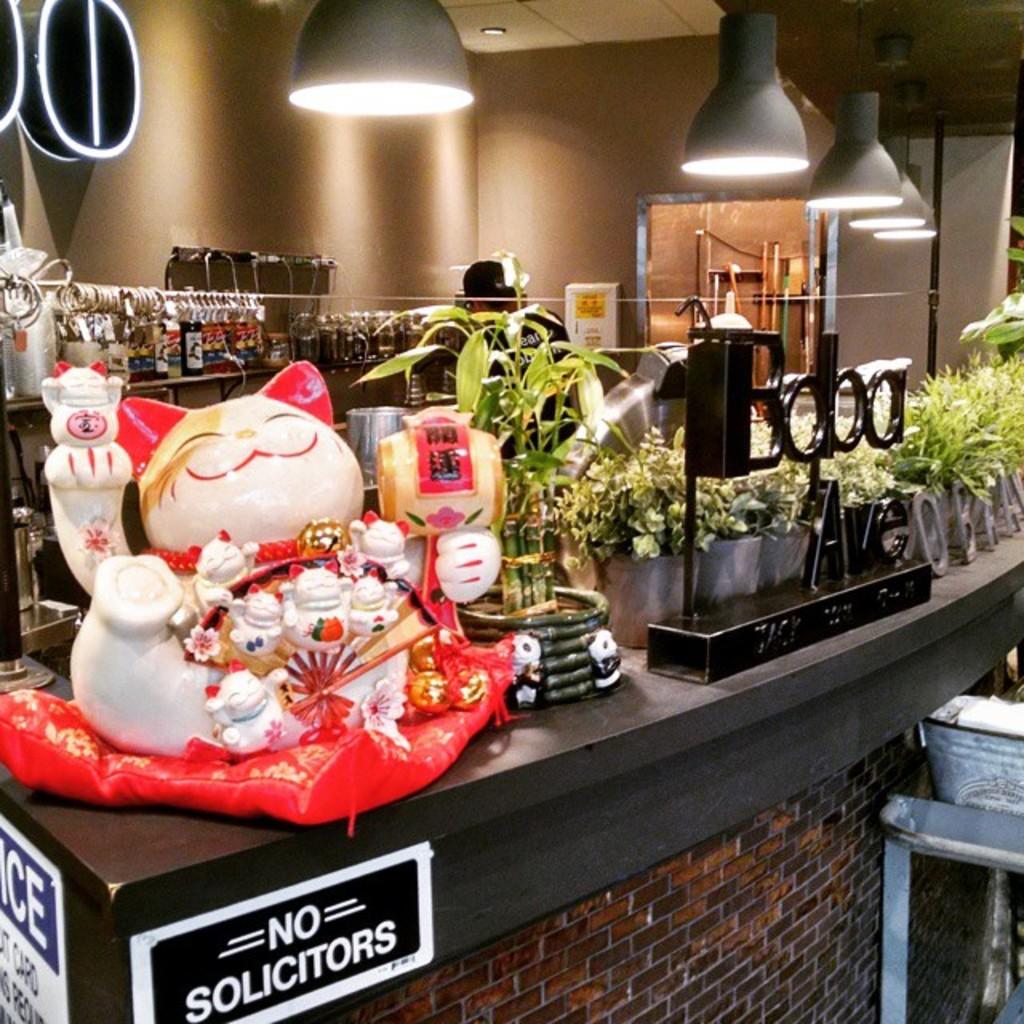What is not allowed?
Give a very brief answer. Solicitors. 